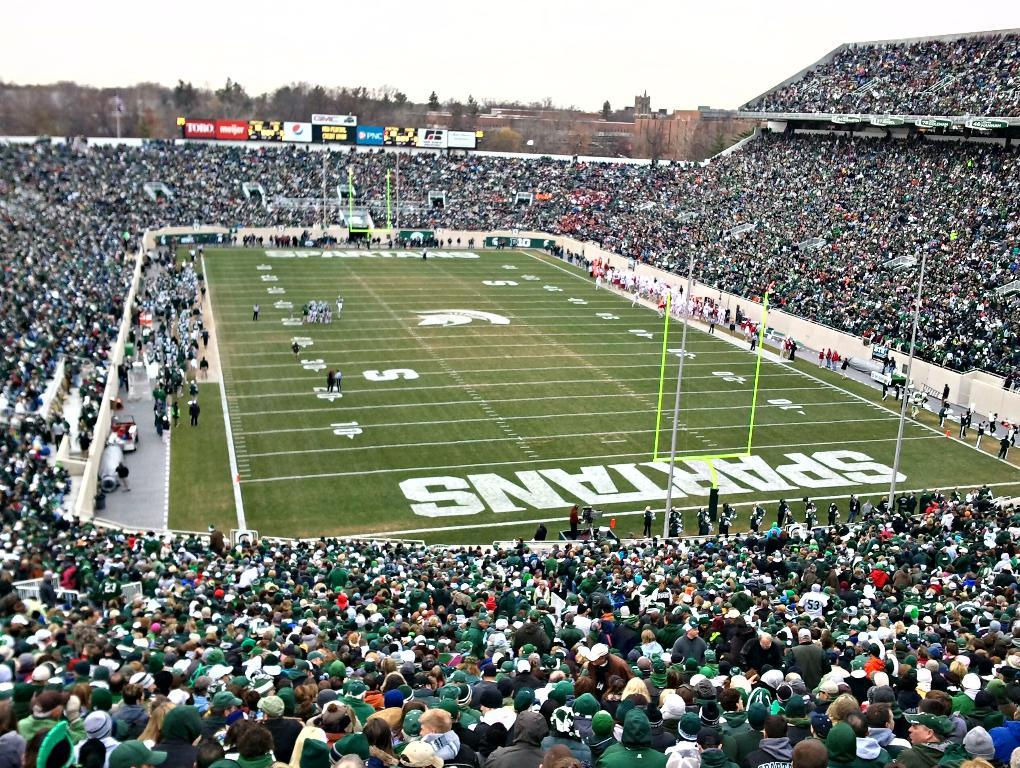<image>
Render a clear and concise summary of the photo. Stadium full of people with the word Spartans on the field. 